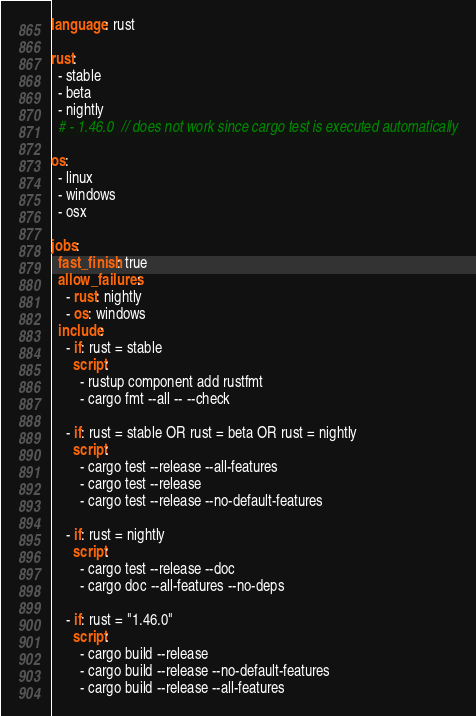Convert code to text. <code><loc_0><loc_0><loc_500><loc_500><_YAML_>language: rust

rust:
  - stable
  - beta
  - nightly
  # - 1.46.0  // does not work since cargo test is executed automatically

os:
  - linux
  - windows
  - osx

jobs:
  fast_finish: true
  allow_failures:
    - rust: nightly
    - os: windows
  include:
    - if: rust = stable
      script:
        - rustup component add rustfmt
        - cargo fmt --all -- --check

    - if: rust = stable OR rust = beta OR rust = nightly
      script:
        - cargo test --release --all-features
        - cargo test --release
        - cargo test --release --no-default-features

    - if: rust = nightly
      script:
        - cargo test --release --doc
        - cargo doc --all-features --no-deps

    - if: rust = "1.46.0"
      script:
        - cargo build --release
        - cargo build --release --no-default-features
        - cargo build --release --all-features</code> 